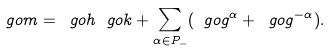Convert formula to latex. <formula><loc_0><loc_0><loc_500><loc_500>\ g o m = \ g o h _ { \ } g o k + \sum _ { \alpha \in P _ { - } } ( \ g o g ^ { \alpha } + \ g o g ^ { - \alpha } ) .</formula> 